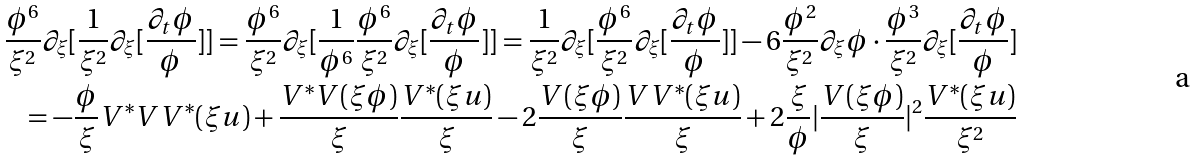Convert formula to latex. <formula><loc_0><loc_0><loc_500><loc_500>\frac { \phi ^ { 6 } } { \xi ^ { 2 } } \partial _ { \xi } [ \frac { 1 } { \xi ^ { 2 } } \partial _ { \xi } [ \frac { \partial _ { t } \phi } { \phi } ] ] = \frac { \phi ^ { 6 } } { \xi ^ { 2 } } \partial _ { \xi } [ \frac { 1 } { \phi ^ { 6 } } \frac { \phi ^ { 6 } } { \xi ^ { 2 } } \partial _ { \xi } [ \frac { \partial _ { t } \phi } { \phi } ] ] = \frac { 1 } { \xi ^ { 2 } } \partial _ { \xi } [ \frac { \phi ^ { 6 } } { \xi ^ { 2 } } \partial _ { \xi } [ \frac { \partial _ { t } \phi } { \phi } ] ] - 6 \frac { \phi ^ { 2 } } { \xi ^ { 2 } } \partial _ { \xi } \phi \cdot \frac { \phi ^ { 3 } } { \xi ^ { 2 } } \partial _ { \xi } [ \frac { \partial _ { t } \phi } { \phi } ] \\ = - \frac { \phi } { \xi } V ^ { \ast } V V ^ { \ast } ( \xi u ) + \frac { V ^ { \ast } V ( \xi \phi ) } { \xi } \frac { V ^ { \ast } ( \xi u ) } { \xi } - 2 \frac { V ( \xi \phi ) } { \xi } \frac { V V ^ { \ast } ( \xi u ) } { \xi } + 2 \frac { \xi } { \phi } | \frac { V ( \xi \phi ) } { \xi } | ^ { 2 } \frac { V ^ { \ast } ( \xi u ) } { \xi ^ { 2 } }</formula> 